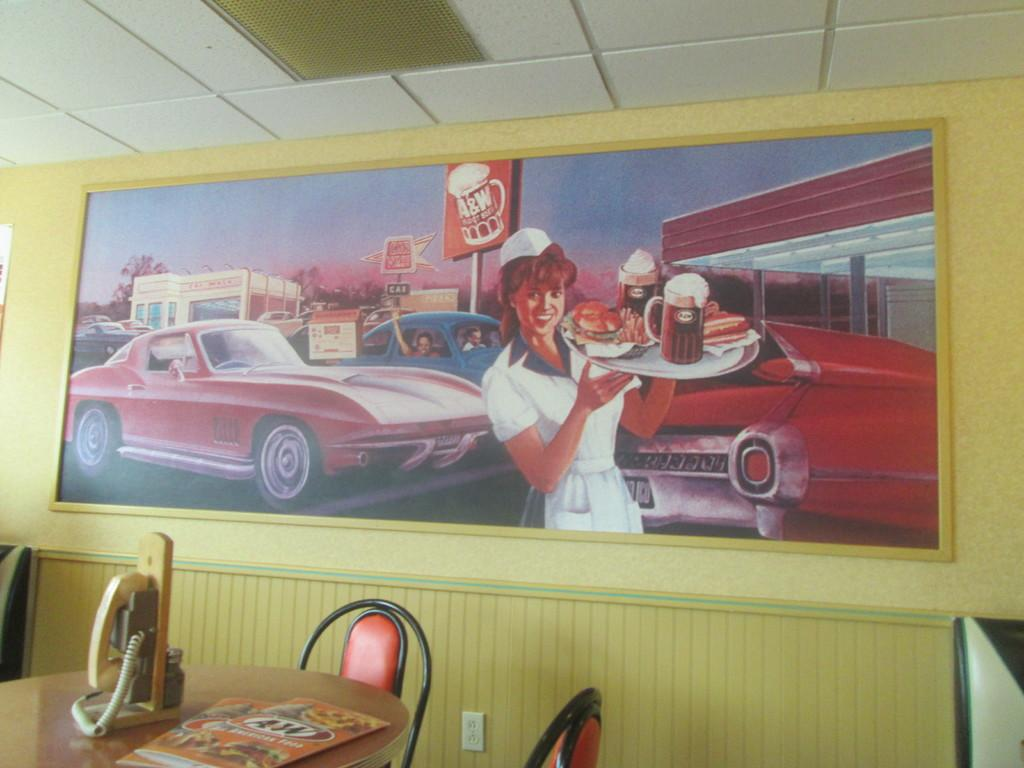What piece of furniture is present in the image? There is a table in the image. What object is placed on the table? There is a telephone on the table. What type of seating is visible in the image? There are chairs in the image. What can be seen hanging on the wall? There is a photo frame on the wall. What part of a building is visible in the image? The roof is visible in the image. Is there a volcano erupting in the image? No, there is no volcano present in the image. What type of sugar is being used to rub on the chairs in the image? There is no sugar or rubbing action depicted in the image; it only shows a table, a telephone, chairs, a photo frame, and a roof. 